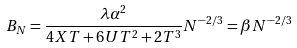Convert formula to latex. <formula><loc_0><loc_0><loc_500><loc_500>B _ { N } = \frac { \lambda \alpha ^ { 2 } } { 4 X T + 6 U T ^ { 2 } + 2 T ^ { 3 } } N ^ { - 2 / 3 } = \beta N ^ { - 2 / 3 }</formula> 